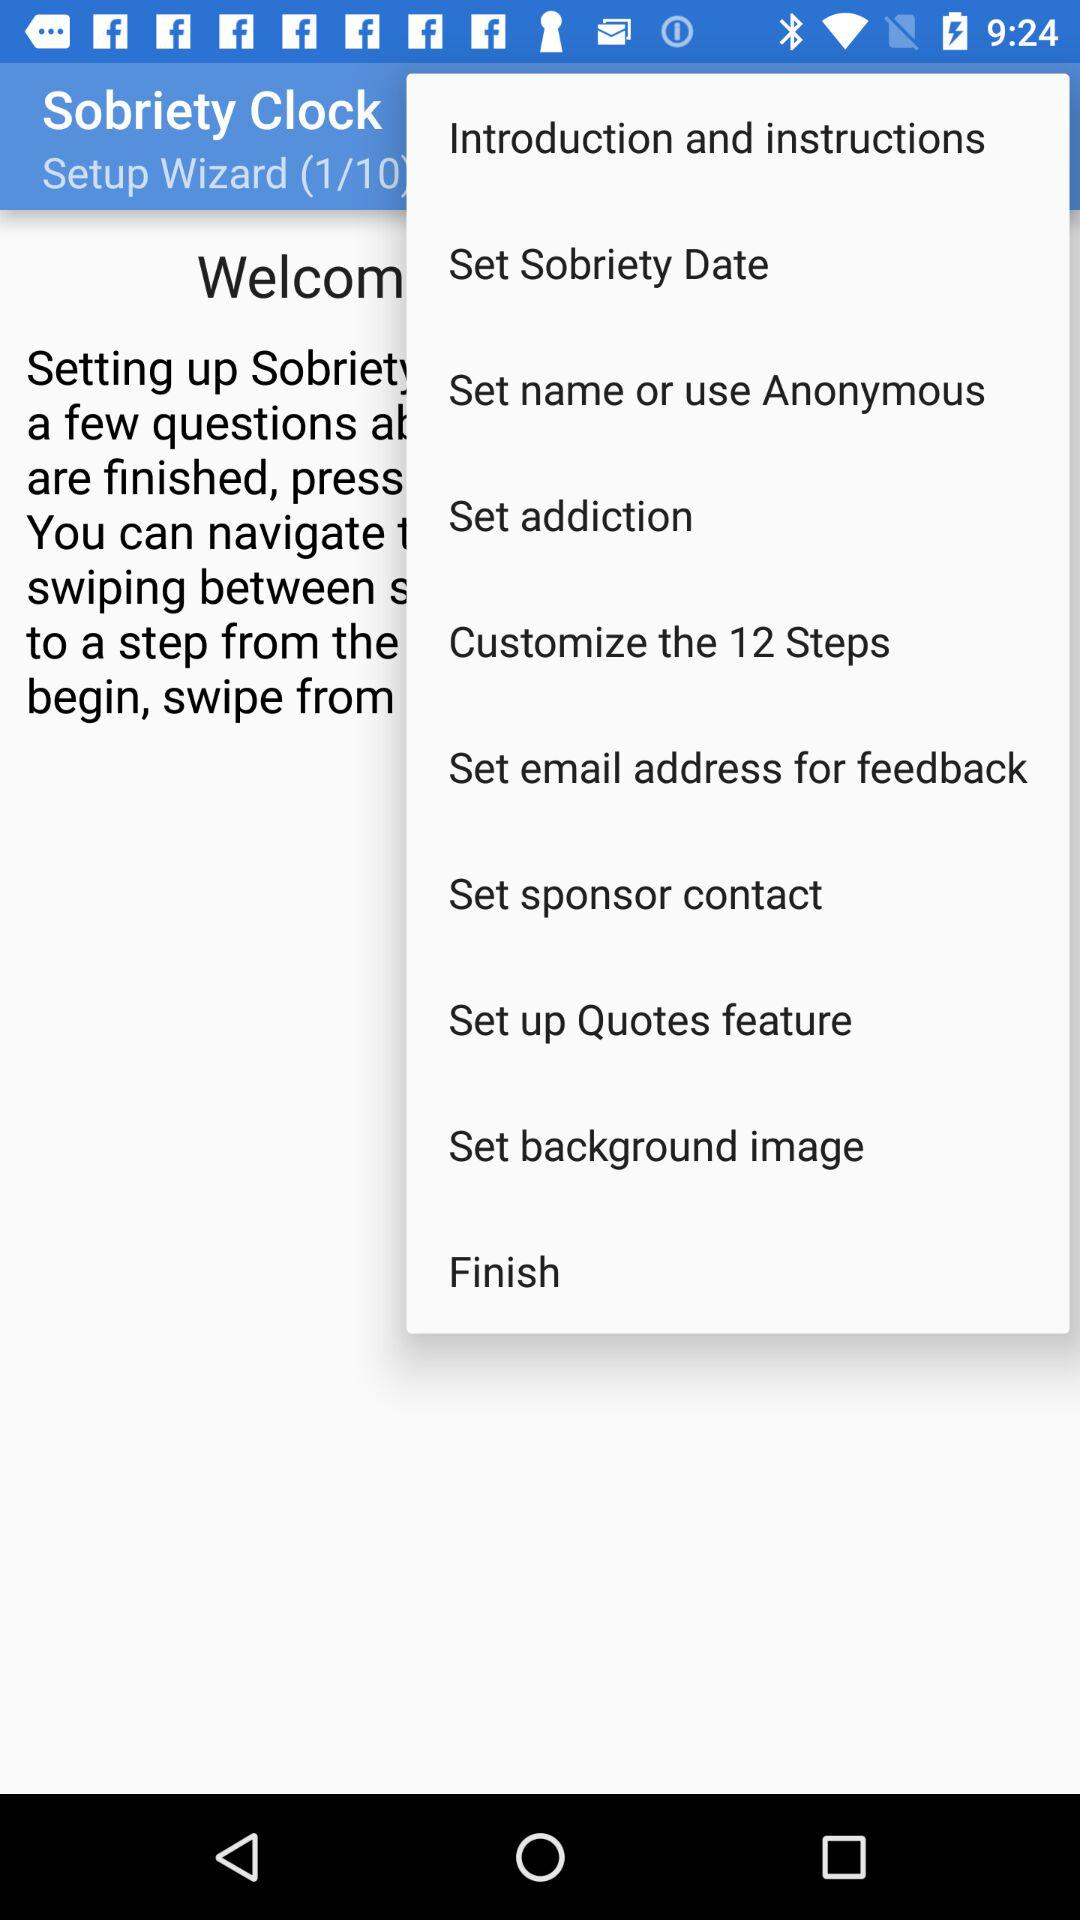What is the application name? The application name is "Sobriety Clock". 